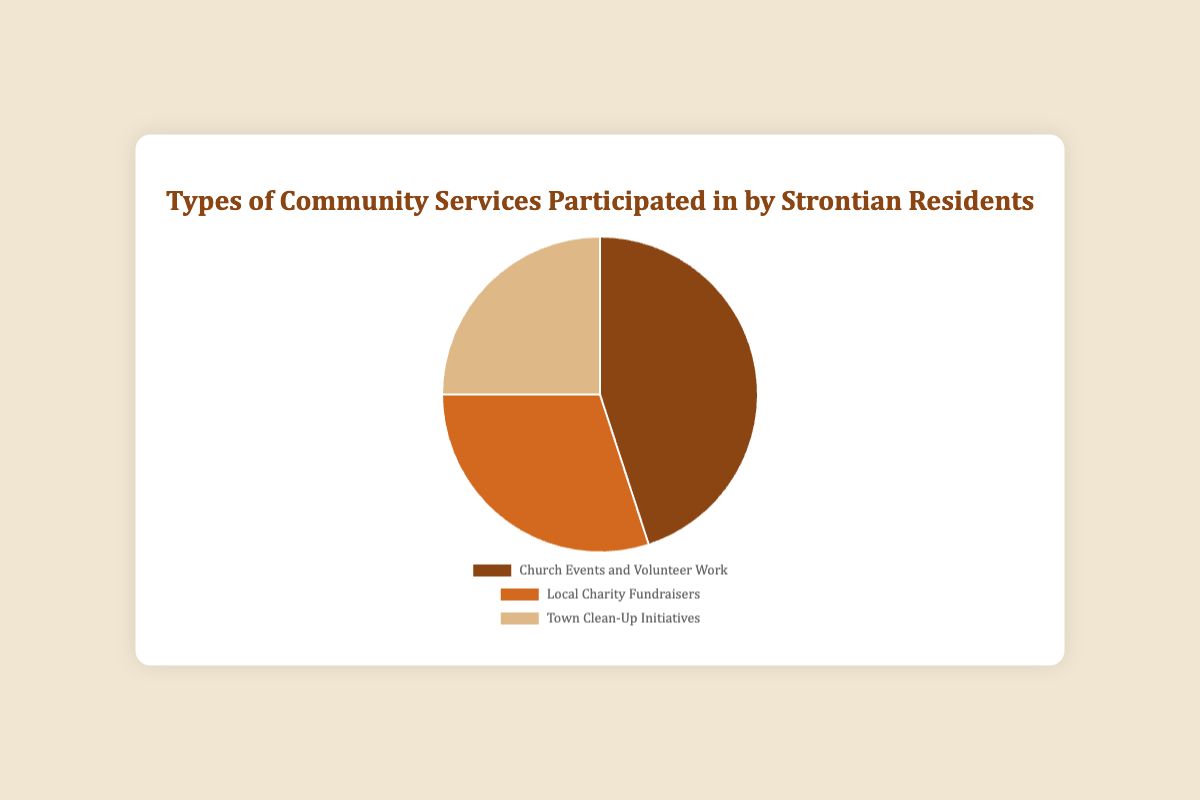Which community service has the highest participation? The figure shows a pie chart with participation percentages. The segment labeled "Church Events and Volunteer Work" has the largest portion, representing 45%.
Answer: Church Events and Volunteer Work How much higher is the participation in Church Events and Volunteer Work compared to Local Charity Fundraisers? The participation in Church Events and Volunteer Work is 45%, while for Local Charity Fundraisers, it is 30%. The difference is calculated as 45% - 30%.
Answer: 15% What is the combined percentage of residents participating in Local Charity Fundraisers and Town Clean-Up Initiatives? Adding the percentages for Local Charity Fundraisers (30%) and Town Clean-Up Initiatives (25%) yields: 30% + 25%.
Answer: 55% Which community service has the smallest participation? By examining the pie chart, the smallest segment corresponds to "Town Clean-Up Initiatives," which is listed as 25%.
Answer: Town Clean-Up Initiatives How much more participation does the most popular community service have than the least popular? The most participated service is Church Events and Volunteer Work at 45%. The least participated is Town Clean-Up Initiatives at 25%. The difference is 45% - 25%.
Answer: 20% Combine the participation percentages for the least and the most popular services. What is this combined percentage? Summing the percentages for Church Events and Volunteer Work (45%) and Town Clean-Up Initiatives (25%) gives 45% + 25%.
Answer: 70% What is the difference in participation between the service with the second highest participation and the service with the least participation? The second most participated service is Local Charity Fundraisers at 30%. The least is Town Clean-Up Initiatives at 25%. The difference is 30% - 25%.
Answer: 5% Which service uses a brownish color in the pie chart? The pie chart segment for "Church Events and Volunteer Work" is brownish in color as depicted.
Answer: Church Events and Volunteer Work 